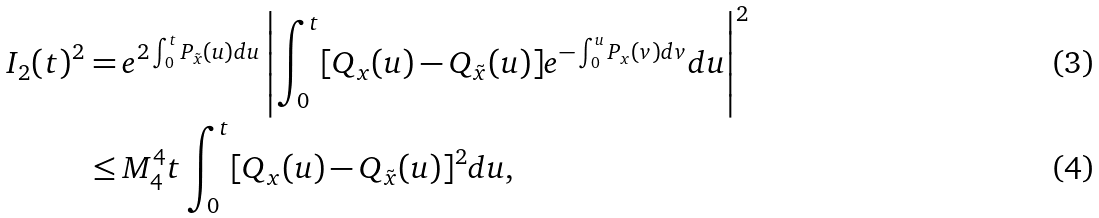Convert formula to latex. <formula><loc_0><loc_0><loc_500><loc_500>I _ { 2 } ( t ) ^ { 2 } = & \, e ^ { 2 \int _ { 0 } ^ { t } P _ { \tilde { x } } ( u ) d u } \left | \int _ { 0 } ^ { t } [ Q _ { x } ( u ) - Q _ { \tilde { x } } ( u ) ] e ^ { - \int _ { 0 } ^ { u } P _ { x } ( v ) d v } d u \right | ^ { 2 } \\ \leq & \, M _ { 4 } ^ { 4 } t \int _ { 0 } ^ { t } [ Q _ { x } ( u ) - Q _ { \tilde { x } } ( u ) ] ^ { 2 } d u ,</formula> 